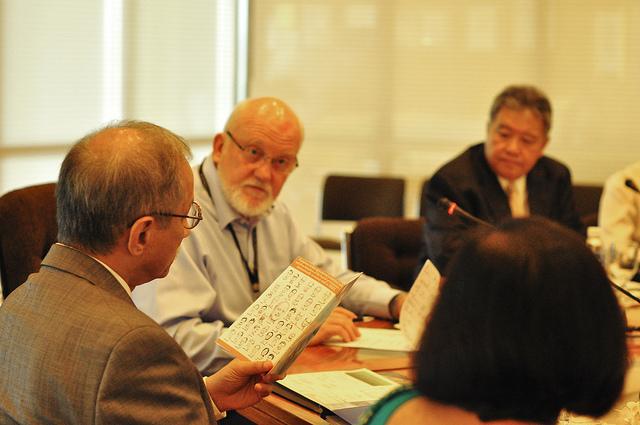How many bald men?
Be succinct. 1. What is the woman's occupation?
Keep it brief. Secretary. Is one of the man reading a menu?
Concise answer only. No. Is this a formal or informal meeting?
Be succinct. Formal. 